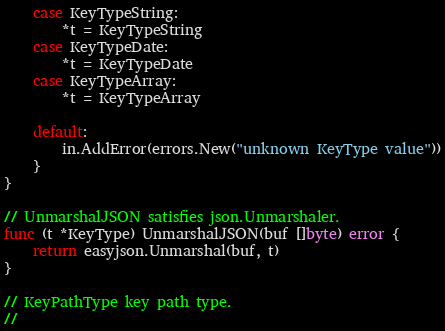<code> <loc_0><loc_0><loc_500><loc_500><_Go_>	case KeyTypeString:
		*t = KeyTypeString
	case KeyTypeDate:
		*t = KeyTypeDate
	case KeyTypeArray:
		*t = KeyTypeArray

	default:
		in.AddError(errors.New("unknown KeyType value"))
	}
}

// UnmarshalJSON satisfies json.Unmarshaler.
func (t *KeyType) UnmarshalJSON(buf []byte) error {
	return easyjson.Unmarshal(buf, t)
}

// KeyPathType key path type.
//</code> 